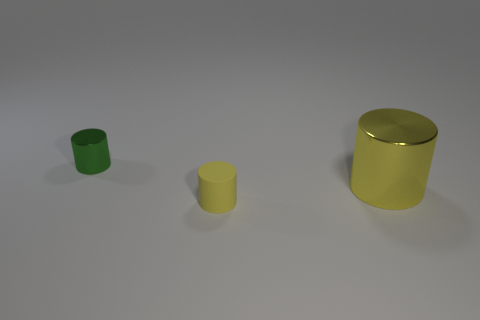Subtract all matte cylinders. How many cylinders are left? 2 Add 1 green metallic objects. How many objects exist? 4 Subtract 1 cylinders. How many cylinders are left? 2 Subtract all green cylinders. How many cylinders are left? 2 Subtract 1 green cylinders. How many objects are left? 2 Subtract all red cylinders. Subtract all purple spheres. How many cylinders are left? 3 Subtract all red spheres. How many red cylinders are left? 0 Subtract all green matte cubes. Subtract all tiny yellow rubber cylinders. How many objects are left? 2 Add 1 large shiny cylinders. How many large shiny cylinders are left? 2 Add 1 yellow objects. How many yellow objects exist? 3 